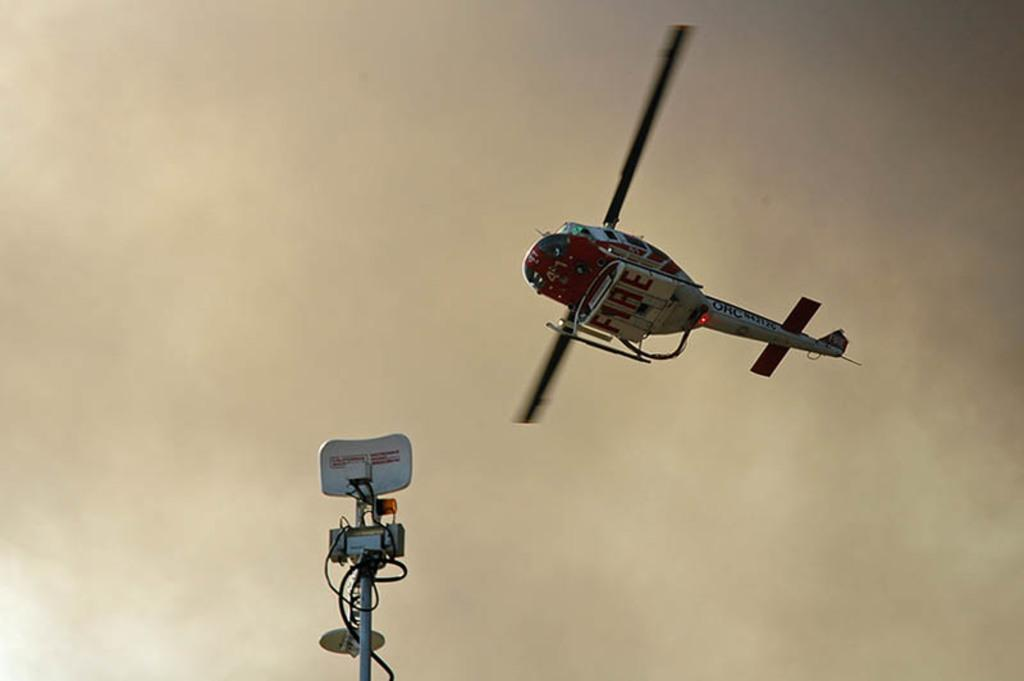<image>
Give a short and clear explanation of the subsequent image. A helicopter has the word fire on the underside. 